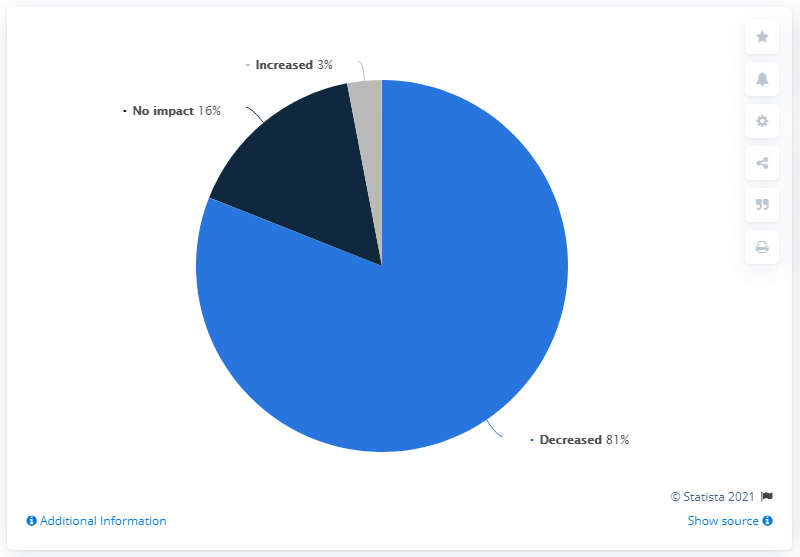Outline some significant characteristics in this image. The sum of two smallest segments is less than the largest segment. The color of the smallest segment is gray, and it is. According to a recent survey, 81% of Indian businesses reported a decrease in cash flow. 